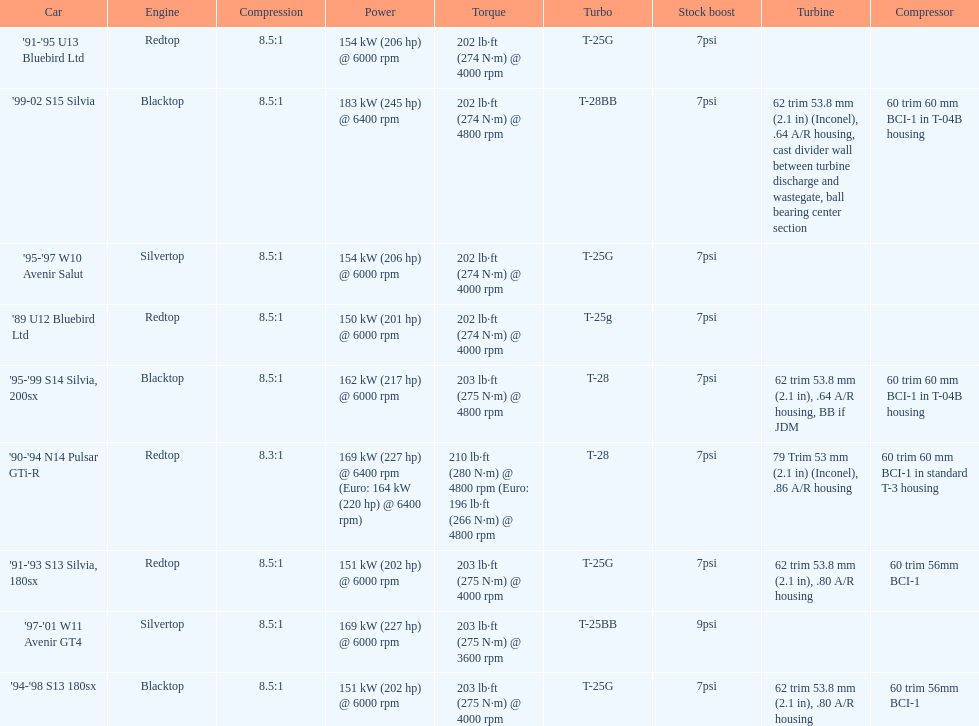Could you help me parse every detail presented in this table? {'header': ['Car', 'Engine', 'Compression', 'Power', 'Torque', 'Turbo', 'Stock boost', 'Turbine', 'Compressor'], 'rows': [["'91-'95 U13 Bluebird Ltd", 'Redtop', '8.5:1', '154\xa0kW (206\xa0hp) @ 6000 rpm', '202\xa0lb·ft (274\xa0N·m) @ 4000 rpm', 'T-25G', '7psi', '', ''], ["'99-02 S15 Silvia", 'Blacktop', '8.5:1', '183\xa0kW (245\xa0hp) @ 6400 rpm', '202\xa0lb·ft (274\xa0N·m) @ 4800 rpm', 'T-28BB', '7psi', '62 trim 53.8\xa0mm (2.1\xa0in) (Inconel), .64 A/R housing, cast divider wall between turbine discharge and wastegate, ball bearing center section', '60 trim 60\xa0mm BCI-1 in T-04B housing'], ["'95-'97 W10 Avenir Salut", 'Silvertop', '8.5:1', '154\xa0kW (206\xa0hp) @ 6000 rpm', '202\xa0lb·ft (274\xa0N·m) @ 4000 rpm', 'T-25G', '7psi', '', ''], ["'89 U12 Bluebird Ltd", 'Redtop', '8.5:1', '150\xa0kW (201\xa0hp) @ 6000 rpm', '202\xa0lb·ft (274\xa0N·m) @ 4000 rpm', 'T-25g', '7psi', '', ''], ["'95-'99 S14 Silvia, 200sx", 'Blacktop', '8.5:1', '162\xa0kW (217\xa0hp) @ 6000 rpm', '203\xa0lb·ft (275\xa0N·m) @ 4800 rpm', 'T-28', '7psi', '62 trim 53.8\xa0mm (2.1\xa0in), .64 A/R housing, BB if JDM', '60 trim 60\xa0mm BCI-1 in T-04B housing'], ["'90-'94 N14 Pulsar GTi-R", 'Redtop', '8.3:1', '169\xa0kW (227\xa0hp) @ 6400 rpm (Euro: 164\xa0kW (220\xa0hp) @ 6400 rpm)', '210\xa0lb·ft (280\xa0N·m) @ 4800 rpm (Euro: 196\xa0lb·ft (266\xa0N·m) @ 4800 rpm', 'T-28', '7psi', '79 Trim 53\xa0mm (2.1\xa0in) (Inconel), .86 A/R housing', '60 trim 60\xa0mm BCI-1 in standard T-3 housing'], ["'91-'93 S13 Silvia, 180sx", 'Redtop', '8.5:1', '151\xa0kW (202\xa0hp) @ 6000 rpm', '203\xa0lb·ft (275\xa0N·m) @ 4000 rpm', 'T-25G', '7psi', '62 trim 53.8\xa0mm (2.1\xa0in), .80 A/R housing', '60 trim 56mm BCI-1'], ["'97-'01 W11 Avenir GT4", 'Silvertop', '8.5:1', '169\xa0kW (227\xa0hp) @ 6000 rpm', '203\xa0lb·ft (275\xa0N·m) @ 3600 rpm', 'T-25BB', '9psi', '', ''], ["'94-'98 S13 180sx", 'Blacktop', '8.5:1', '151\xa0kW (202\xa0hp) @ 6000 rpm', '203\xa0lb·ft (275\xa0N·m) @ 4000 rpm', 'T-25G', '7psi', '62 trim 53.8\xa0mm (2.1\xa0in), .80 A/R housing', '60 trim 56mm BCI-1']]} Which engine has the smallest compression rate? '90-'94 N14 Pulsar GTi-R. 